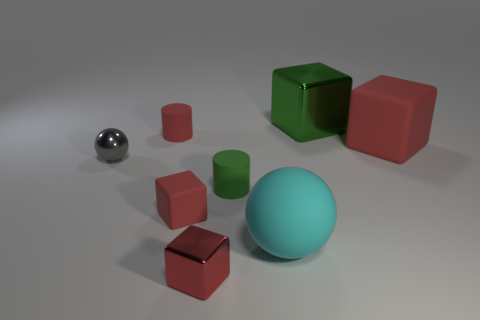What color is the big sphere that is made of the same material as the tiny red cylinder?
Keep it short and to the point. Cyan. Is the number of small cyan spheres greater than the number of red rubber cylinders?
Your answer should be very brief. No. There is a cube that is behind the big sphere and in front of the small gray ball; what is its size?
Provide a short and direct response. Small. There is a cylinder that is the same color as the large rubber block; what is it made of?
Give a very brief answer. Rubber. Are there an equal number of large metallic cubes in front of the big shiny cube and tiny green metal objects?
Offer a very short reply. Yes. Do the gray metallic thing and the green cylinder have the same size?
Your response must be concise. Yes. The large thing that is both behind the tiny gray ball and in front of the large green metallic block is what color?
Ensure brevity in your answer.  Red. There is a cylinder that is to the right of the tiny cube in front of the cyan matte ball; what is it made of?
Keep it short and to the point. Rubber. The shiny thing that is the same shape as the cyan rubber object is what size?
Offer a very short reply. Small. There is a tiny cylinder that is behind the small green rubber cylinder; does it have the same color as the tiny matte block?
Your answer should be compact. Yes. 